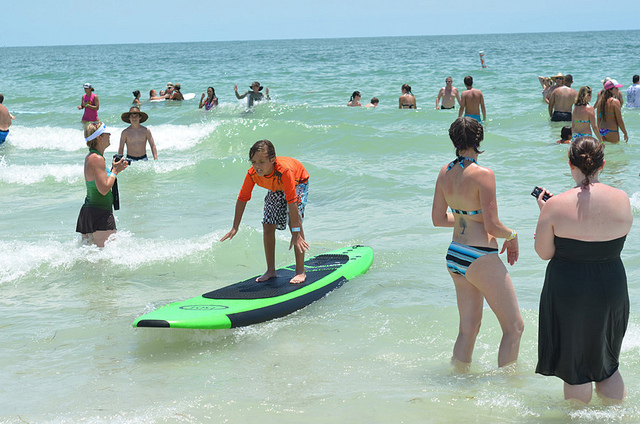If you could turn this scene into a movie, what genre would it be and why? I would turn this scene into an adventurous family movie. The joy and excitement of surfing, swimming, and spending time together at the beach perfectly encapsulate the spirit of a thrilling and heartwarming adventure. Describe a creative and imaginative backstory for the boy surfing. The boy, named Leo, discovered an ancient surfboard buried in the sands of this beach. Legend has it that this surfboard has magical powers to control the waves. One day, while exploring the shoreline, he stumbled across it and decided to give it a try. As soon as Leo hopped on the board, the waves seemed to listen to his every command, carrying him gracefully across the water. Little did he know, this surfboard held the key to a hidden underwater city, waiting to be discovered by a brave and curious soul. 